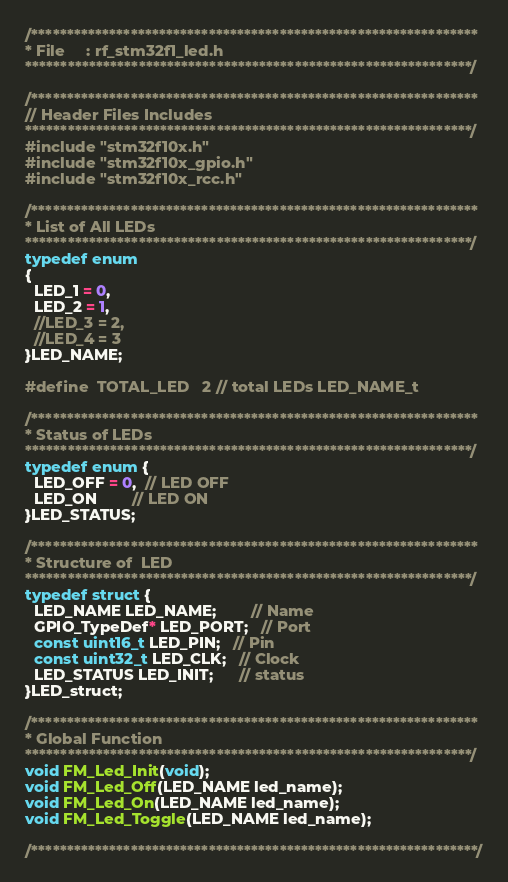<code> <loc_0><loc_0><loc_500><loc_500><_C_>/***************************************************************
* File     : rf_stm32f1_led.h
***************************************************************/

/***************************************************************
// Header Files Includes
***************************************************************/
#include "stm32f10x.h"
#include "stm32f10x_gpio.h"
#include "stm32f10x_rcc.h"

/***************************************************************
* List of All LEDs
***************************************************************/
typedef enum
{
  LED_1 = 0,
  LED_2 = 1,
  //LED_3 = 2,
  //LED_4 = 3
}LED_NAME;

#define  TOTAL_LED   2 // total LEDs LED_NAME_t

/***************************************************************
* Status of LEDs
***************************************************************/
typedef enum {
  LED_OFF = 0,  // LED OFF
  LED_ON        // LED ON
}LED_STATUS;

/***************************************************************
* Structure of  LED
***************************************************************/
typedef struct {
  LED_NAME LED_NAME;        // Name
  GPIO_TypeDef* LED_PORT;   // Port
  const uint16_t LED_PIN;   // Pin
  const uint32_t LED_CLK;   // Clock
  LED_STATUS LED_INIT;      // status
}LED_struct;

/***************************************************************
* Global Function
***************************************************************/
void FM_Led_Init(void);
void FM_Led_Off(LED_NAME led_name);
void FM_Led_On(LED_NAME led_name);
void FM_Led_Toggle(LED_NAME led_name);

/***************************************************************/
</code> 